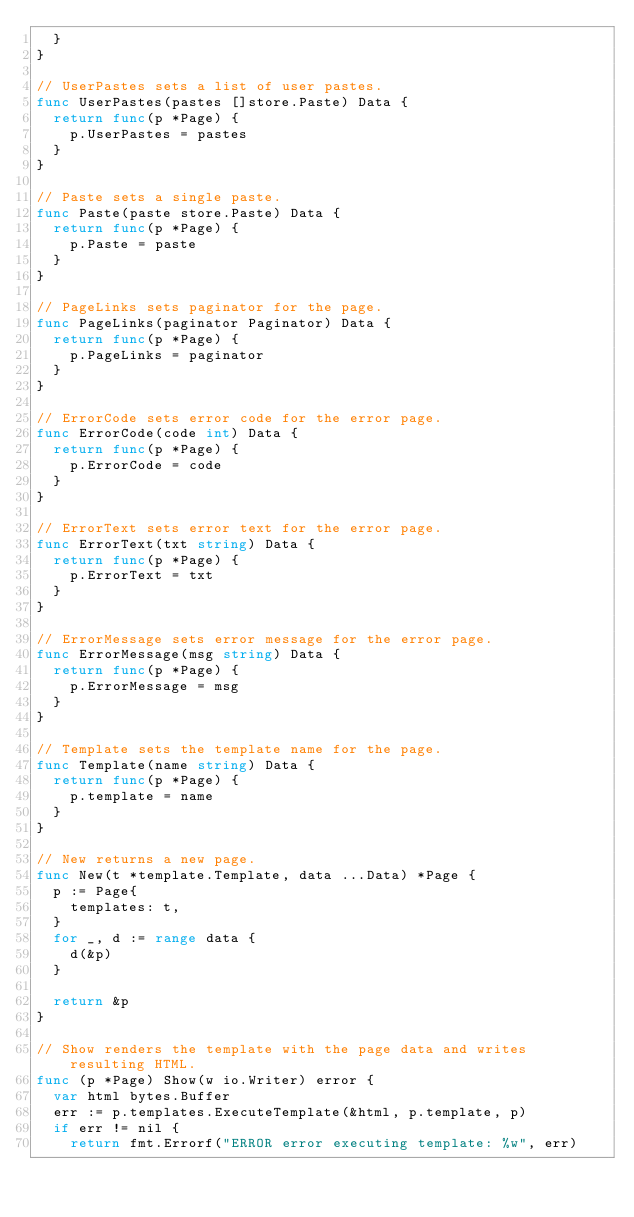Convert code to text. <code><loc_0><loc_0><loc_500><loc_500><_Go_>	}
}

// UserPastes sets a list of user pastes.
func UserPastes(pastes []store.Paste) Data {
	return func(p *Page) {
		p.UserPastes = pastes
	}
}

// Paste sets a single paste.
func Paste(paste store.Paste) Data {
	return func(p *Page) {
		p.Paste = paste
	}
}

// PageLinks sets paginator for the page.
func PageLinks(paginator Paginator) Data {
	return func(p *Page) {
		p.PageLinks = paginator
	}
}

// ErrorCode sets error code for the error page.
func ErrorCode(code int) Data {
	return func(p *Page) {
		p.ErrorCode = code
	}
}

// ErrorText sets error text for the error page.
func ErrorText(txt string) Data {
	return func(p *Page) {
		p.ErrorText = txt
	}
}

// ErrorMessage sets error message for the error page.
func ErrorMessage(msg string) Data {
	return func(p *Page) {
		p.ErrorMessage = msg
	}
}

// Template sets the template name for the page.
func Template(name string) Data {
	return func(p *Page) {
		p.template = name
	}
}

// New returns a new page.
func New(t *template.Template, data ...Data) *Page {
	p := Page{
		templates: t,
	}
	for _, d := range data {
		d(&p)
	}

	return &p
}

// Show renders the template with the page data and writes resulting HTML.
func (p *Page) Show(w io.Writer) error {
	var html bytes.Buffer
	err := p.templates.ExecuteTemplate(&html, p.template, p)
	if err != nil {
		return fmt.Errorf("ERROR error executing template: %w", err)</code> 